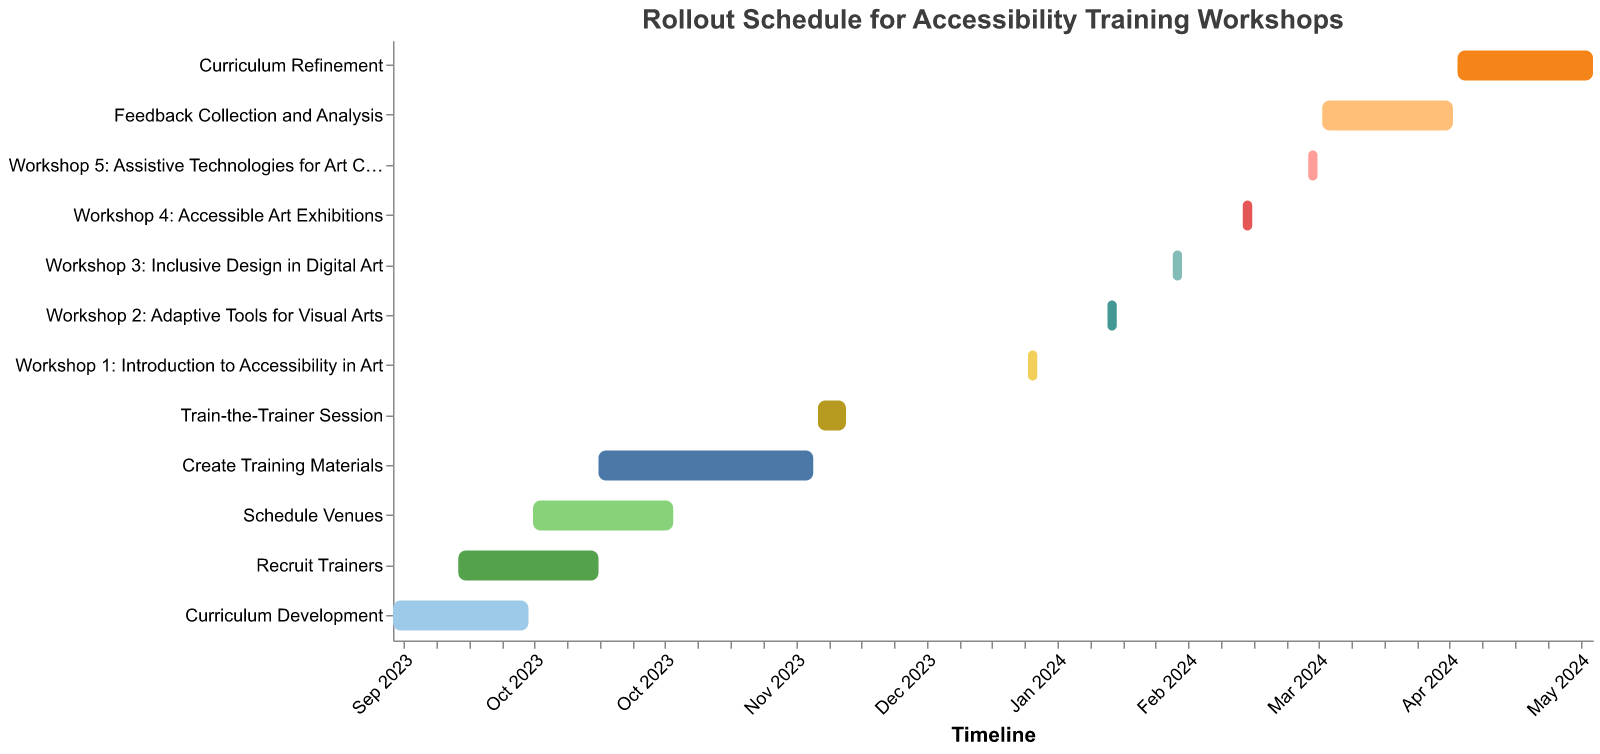What's the title of the figure? The title of the figure is located at the top and provides a summary of the chart's content. In this case, it reads "Rollout Schedule for Accessibility Training Workshops."
Answer: Rollout Schedule for Accessibility Training Workshops How many tasks start in September 2023? To answer this, we need to count the tasks with a start date in September 2023 by looking at the x-axis and corresponding bars. "Curriculum Development" starts on September 1, and "Recruit Trainers" starts on September 15.
Answer: 2 Which task has the longest duration? To determine this, review the duration values displayed in the tooltips when hovered over each bar or compare the lengths of the bars. "Create Training Materials" with a duration of 47 days is the longest.
Answer: Create Training Materials When does the "Feedback Collection and Analysis" task end? Look at the bar labeled "Feedback Collection and Analysis" and refer to the tooltip or the x-axis endpoint of the bar. It ends on April 15, 2024.
Answer: April 15, 2024 How long is the whole project duration from the first to the last task? Identify the start date of the first task ("Curriculum Development" on September 1, 2023) and the end date of the last task ("Curriculum Refinement" on May 15, 2024). Calculating the difference between these two dates gives the total project duration.
Answer: 258 days Which task overlaps with both "Recruit Trainers" and "Create Training Materials"? Identify tasks that have overlapping bar ranges from the start to end dates of both "Recruit Trainers" and "Create Training Materials." "Schedule Venues" overlaps with both as it runs from October 1 to October 31, 2023.
Answer: Schedule Venues What is the duration of "Train-the-Trainer Session"? Refer to the corresponding bar or tooltip for "Train-the-Trainer Session" and check its duration. It lasts for 7 days.
Answer: 7 days How many workshops are scheduled in total? Workshops are easily identifiable as they start with "Workshop" in their task names. Count the number of these bars.
Answer: 5 Does "Curriculum Refinement" start before or after "Feedback Collection and Analysis" ends? Check the end date of "Feedback Collection and Analysis" (April 15, 2024) and the start date of "Curriculum Refinement" (April 16, 2024). Since the latter starts the day after the former ends, it starts after.
Answer: After How many tasks are scheduled to start in 2024? To determine this, count the tasks with start dates in 2024 by inspecting the x-axis dates.
Answer: 7 